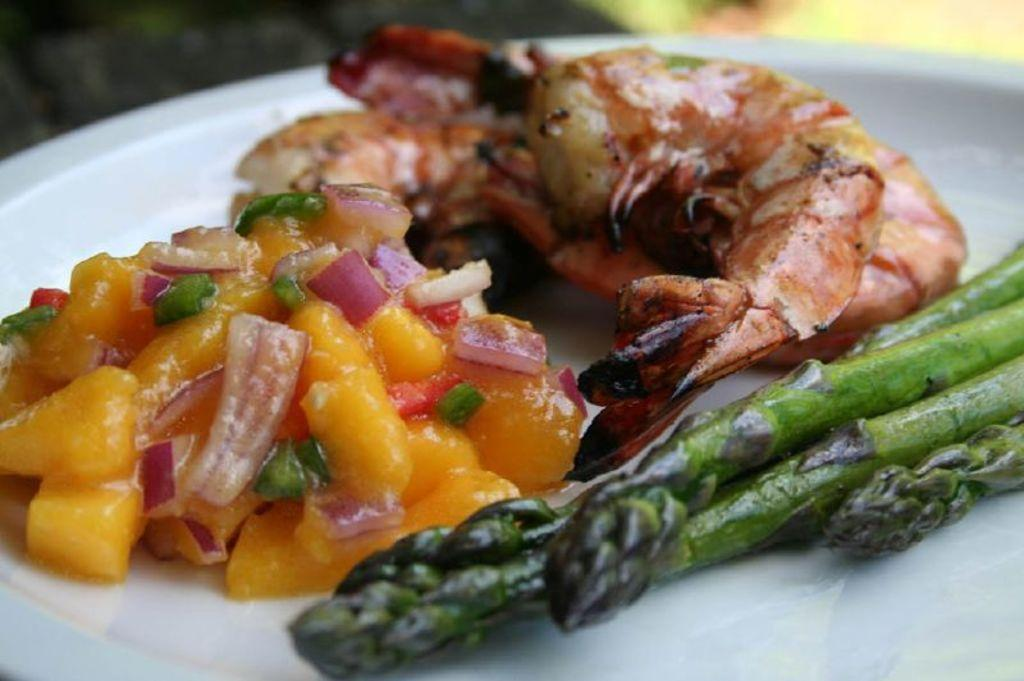What is present in the image related to food? There is food in the image. How is the food arranged or contained in the image? The food is in a plate. Can you hear the sound of the toe in the image? There is no toe present in the image, and therefore no sound can be heard. 